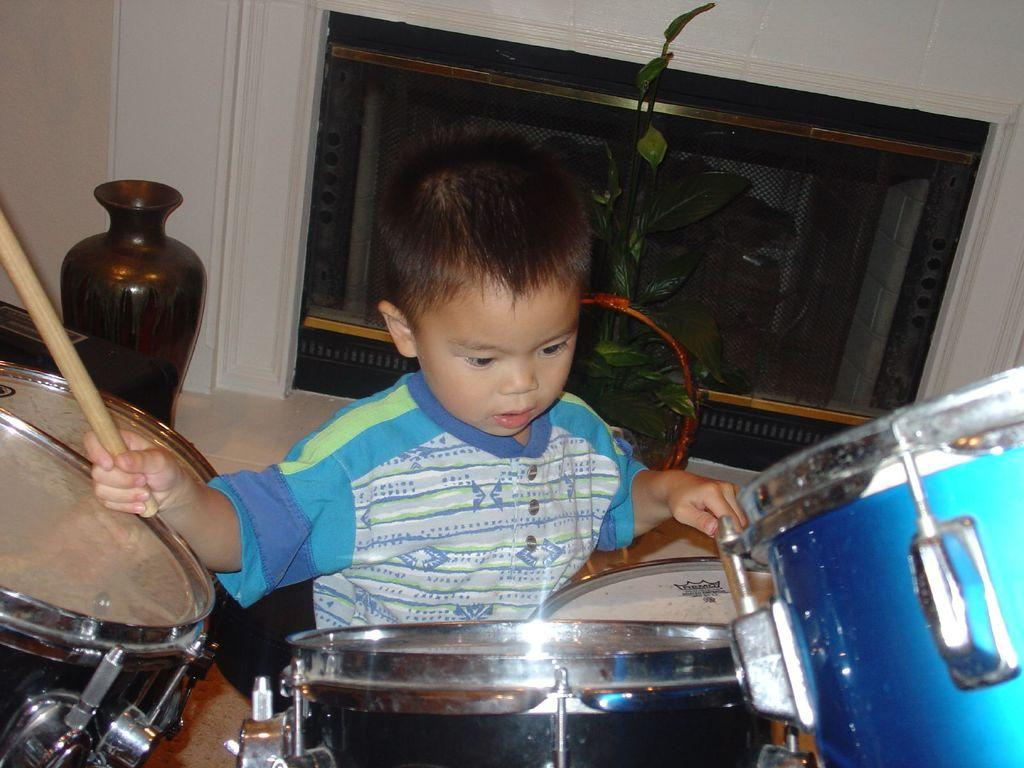What is the main subject of the image? The main subject of the image is a little boy. What is the boy doing in the image? The boy is beating drums in the image. What color is the boy's t-shirt? The boy is wearing a blue color t-shirt. What type of brush is the boy using to paint in the image? There is no brush or painting activity present in the image; the boy is beating drums. 